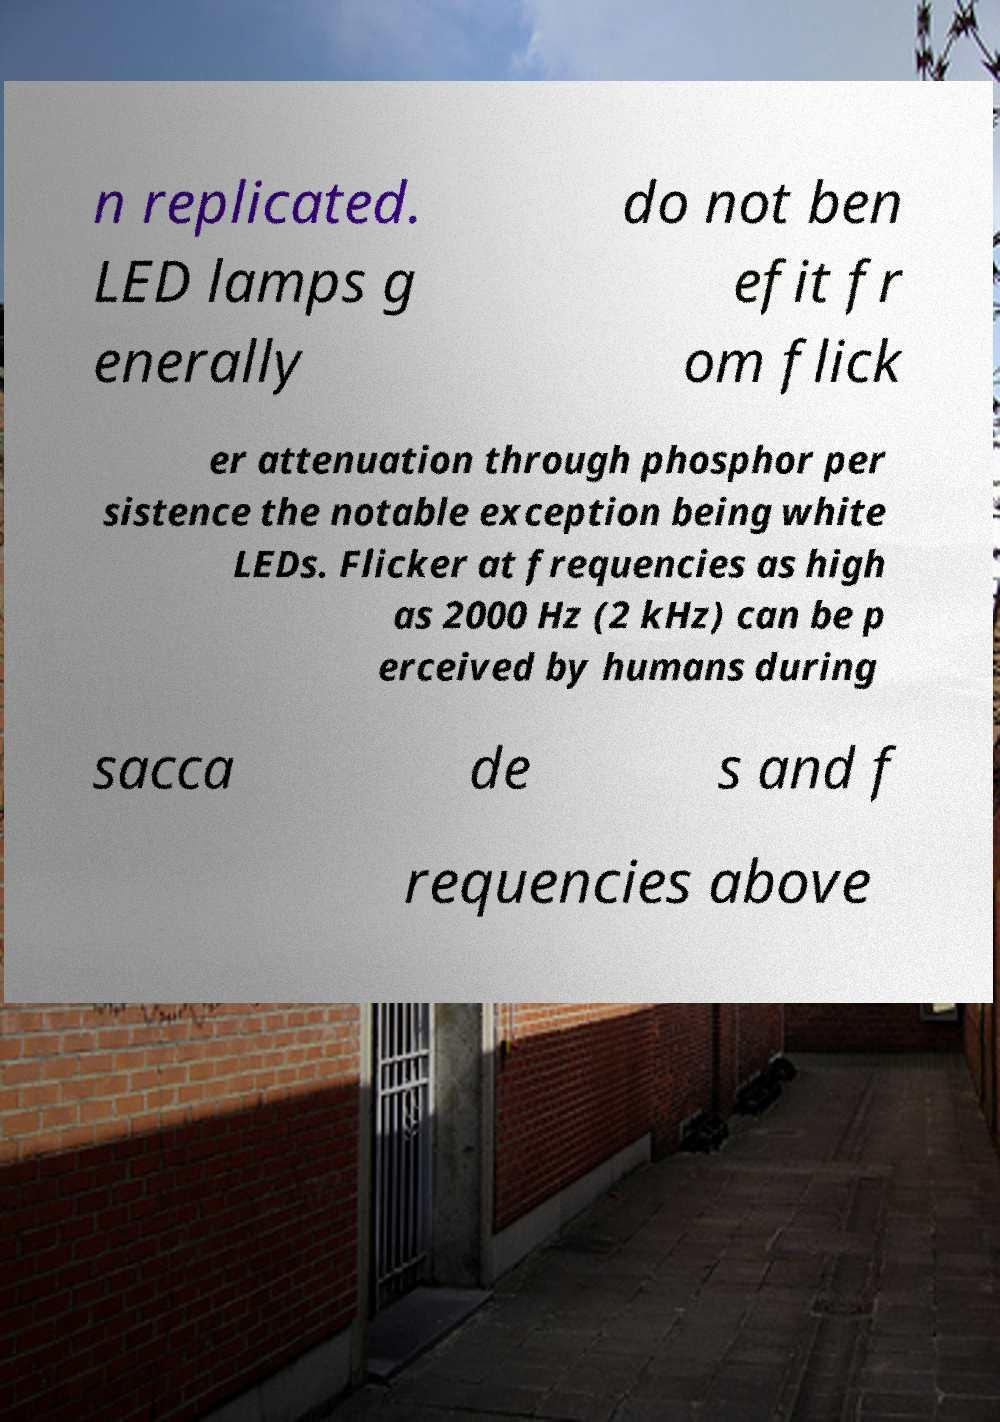I need the written content from this picture converted into text. Can you do that? n replicated. LED lamps g enerally do not ben efit fr om flick er attenuation through phosphor per sistence the notable exception being white LEDs. Flicker at frequencies as high as 2000 Hz (2 kHz) can be p erceived by humans during sacca de s and f requencies above 